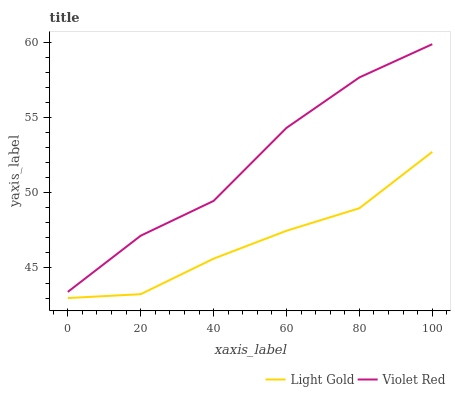Does Light Gold have the minimum area under the curve?
Answer yes or no. Yes. Does Violet Red have the maximum area under the curve?
Answer yes or no. Yes. Does Light Gold have the maximum area under the curve?
Answer yes or no. No. Is Light Gold the smoothest?
Answer yes or no. Yes. Is Violet Red the roughest?
Answer yes or no. Yes. Is Light Gold the roughest?
Answer yes or no. No. Does Light Gold have the lowest value?
Answer yes or no. Yes. Does Violet Red have the highest value?
Answer yes or no. Yes. Does Light Gold have the highest value?
Answer yes or no. No. Is Light Gold less than Violet Red?
Answer yes or no. Yes. Is Violet Red greater than Light Gold?
Answer yes or no. Yes. Does Light Gold intersect Violet Red?
Answer yes or no. No. 